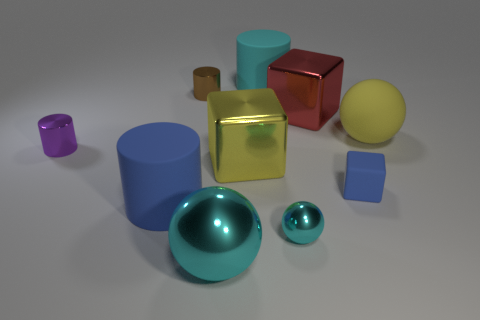Subtract all cylinders. How many objects are left? 6 Subtract 0 gray blocks. How many objects are left? 10 Subtract all tiny cylinders. Subtract all brown objects. How many objects are left? 7 Add 3 small metallic cylinders. How many small metallic cylinders are left? 5 Add 6 blue objects. How many blue objects exist? 8 